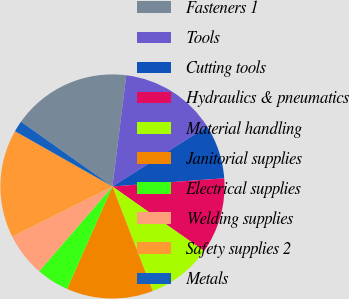Convert chart to OTSL. <chart><loc_0><loc_0><loc_500><loc_500><pie_chart><fcel>Fasteners 1<fcel>Tools<fcel>Cutting tools<fcel>Hydraulics & pneumatics<fcel>Material handling<fcel>Janitorial supplies<fcel>Electrical supplies<fcel>Welding supplies<fcel>Safety supplies 2<fcel>Metals<nl><fcel>17.16%<fcel>14.05%<fcel>7.82%<fcel>10.93%<fcel>9.38%<fcel>12.49%<fcel>4.71%<fcel>6.26%<fcel>15.6%<fcel>1.6%<nl></chart> 